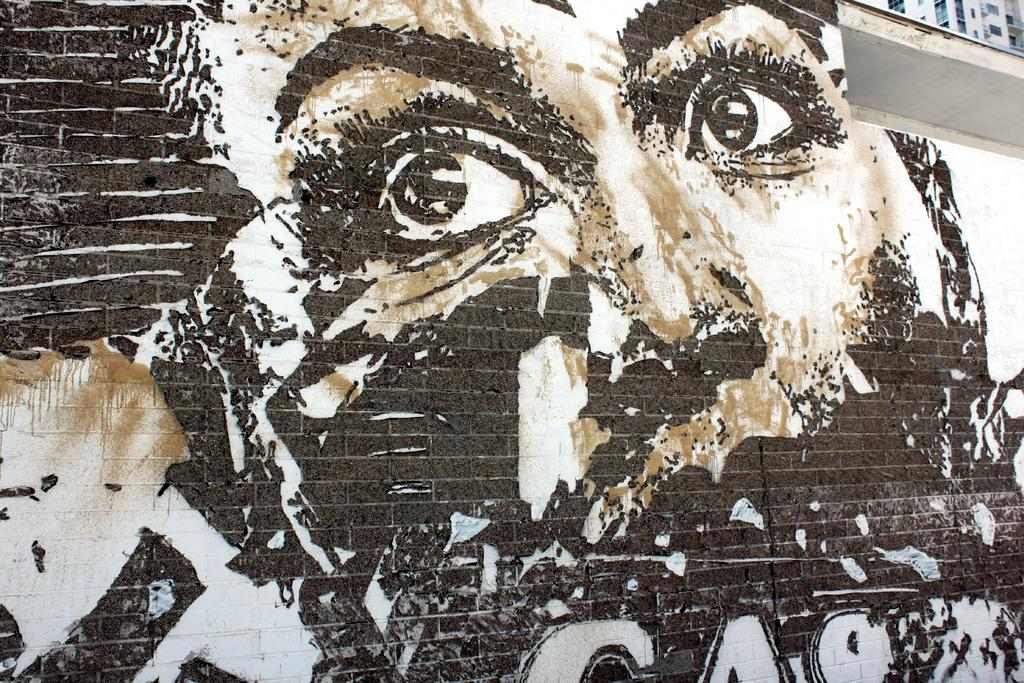What is present on the wall in the image? There is an art of a person on the wall. What can be found at the bottom of the art? There is some text at the bottom of the art. Where is the object located in the image? The object is in the top right corner of the image. What is the weather like on the island depicted in the art? There is no island depicted in the art; it features a person and text. What type of cast is present in the image? There is no cast present in the image; it only contains a wall with art, text, and an object. 